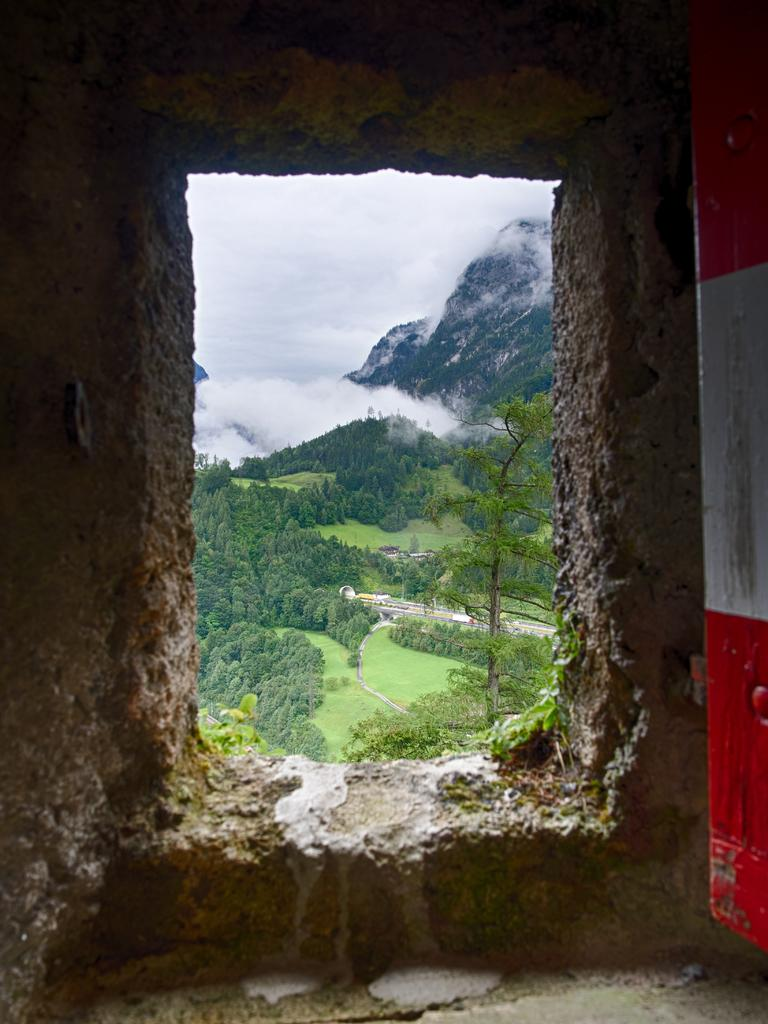What is present on the right side of the image? There is a white and red color object on the right side of the image. What can be seen in the background of the image? Hills, trees, plants, and the sky are visible in the background of the image. What type of structure is present in the image? There is a wall in the image. What type of food is being prepared on the wall in the image? There is no food preparation or cooking activity visible in the image; the wall is a structure and not related to food. 